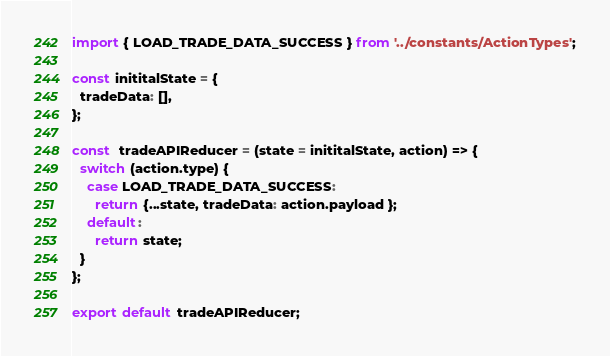<code> <loc_0><loc_0><loc_500><loc_500><_JavaScript_>import { LOAD_TRADE_DATA_SUCCESS } from '../constants/ActionTypes';

const inititalState = {
  tradeData: [],
};

const  tradeAPIReducer = (state = inititalState, action) => {
  switch (action.type) {
    case LOAD_TRADE_DATA_SUCCESS:
      return {...state, tradeData: action.payload };
    default:
      return state;
  }
};

export default tradeAPIReducer;
</code> 